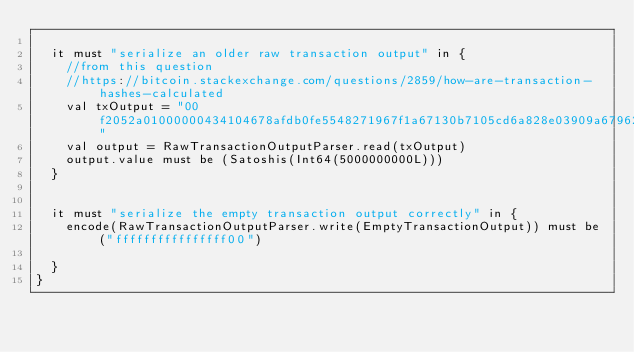Convert code to text. <code><loc_0><loc_0><loc_500><loc_500><_Scala_>
  it must "serialize an older raw transaction output" in {
    //from this question
    //https://bitcoin.stackexchange.com/questions/2859/how-are-transaction-hashes-calculated
    val txOutput = "00f2052a01000000434104678afdb0fe5548271967f1a67130b7105cd6a828e03909a67962e0ea1f61deb649f6bc3f4cef38c4f35504e51ec112de5c384df7ba0b8d578a4c702b6bf11d5fac"
    val output = RawTransactionOutputParser.read(txOutput)
    output.value must be (Satoshis(Int64(5000000000L)))
  }


  it must "serialize the empty transaction output correctly" in {
    encode(RawTransactionOutputParser.write(EmptyTransactionOutput)) must be ("ffffffffffffffff00")

  }
}
</code> 